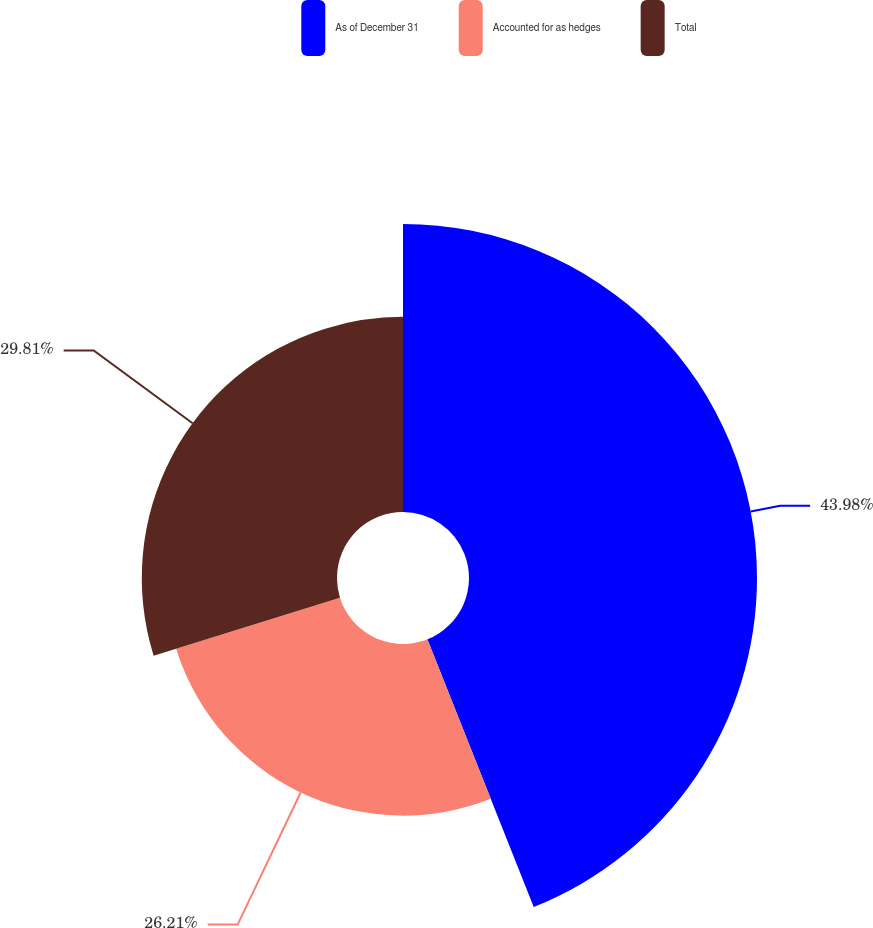<chart> <loc_0><loc_0><loc_500><loc_500><pie_chart><fcel>As of December 31<fcel>Accounted for as hedges<fcel>Total<nl><fcel>43.98%<fcel>26.21%<fcel>29.81%<nl></chart> 